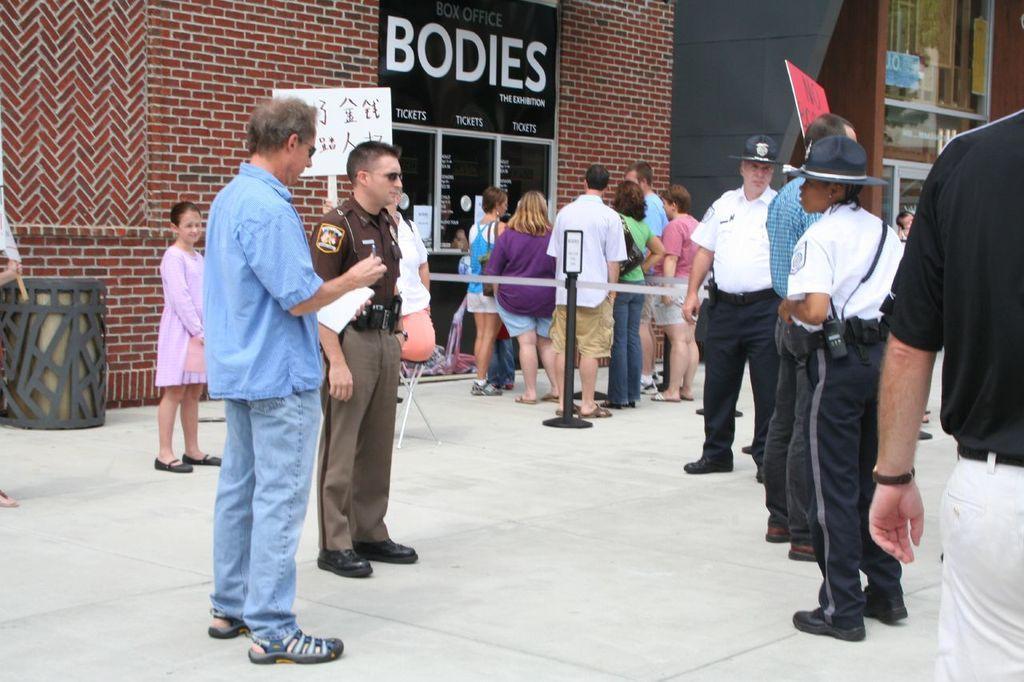How would you summarize this image in a sentence or two? In this image we can see people standing on the floor, barrier poles, bins, walls and advertisement board. 